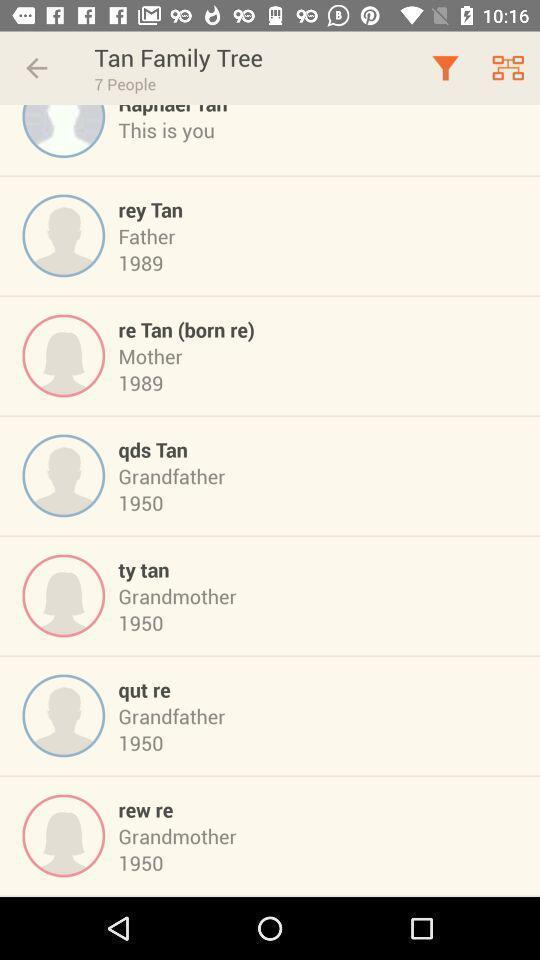Describe the visual elements of this screenshot. Screen displaying the list of people with years. 